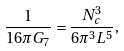Convert formula to latex. <formula><loc_0><loc_0><loc_500><loc_500>\frac { 1 } { 1 6 \pi G _ { 7 } } = \frac { N _ { c } ^ { 3 } } { 6 \pi ^ { 3 } L ^ { 5 } } ,</formula> 